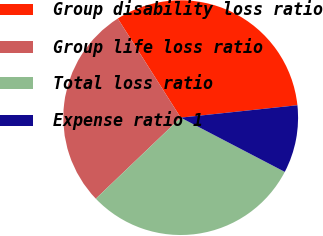<chart> <loc_0><loc_0><loc_500><loc_500><pie_chart><fcel>Group disability loss ratio<fcel>Group life loss ratio<fcel>Total loss ratio<fcel>Expense ratio 1<nl><fcel>32.32%<fcel>28.13%<fcel>30.22%<fcel>9.33%<nl></chart> 